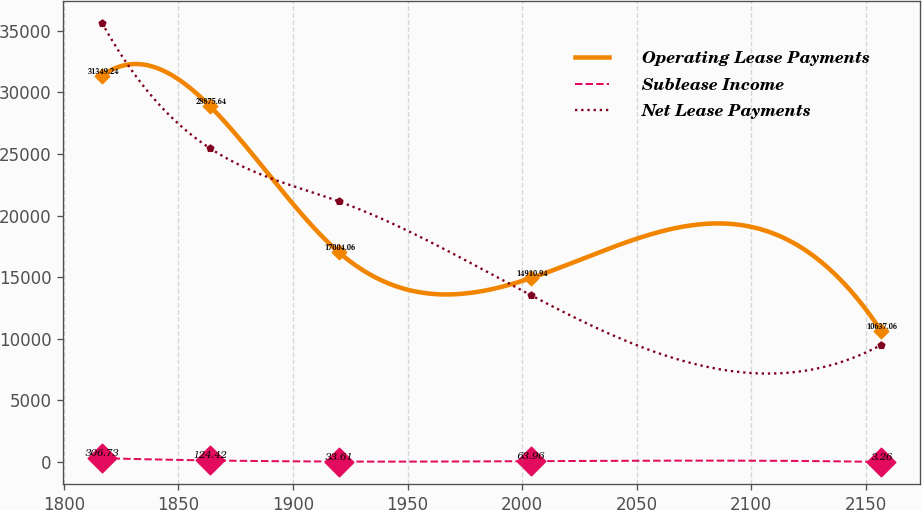Convert chart. <chart><loc_0><loc_0><loc_500><loc_500><line_chart><ecel><fcel>Operating Lease Payments<fcel>Sublease Income<fcel>Net Lease Payments<nl><fcel>1816.62<fcel>31349.2<fcel>306.73<fcel>35630.2<nl><fcel>1863.75<fcel>28875.6<fcel>124.42<fcel>25456.6<nl><fcel>1920.08<fcel>17004.1<fcel>33.61<fcel>21141.5<nl><fcel>2003.67<fcel>14910.9<fcel>63.96<fcel>13550.6<nl><fcel>2156.66<fcel>10637.1<fcel>3.26<fcel>9498.46<nl></chart> 